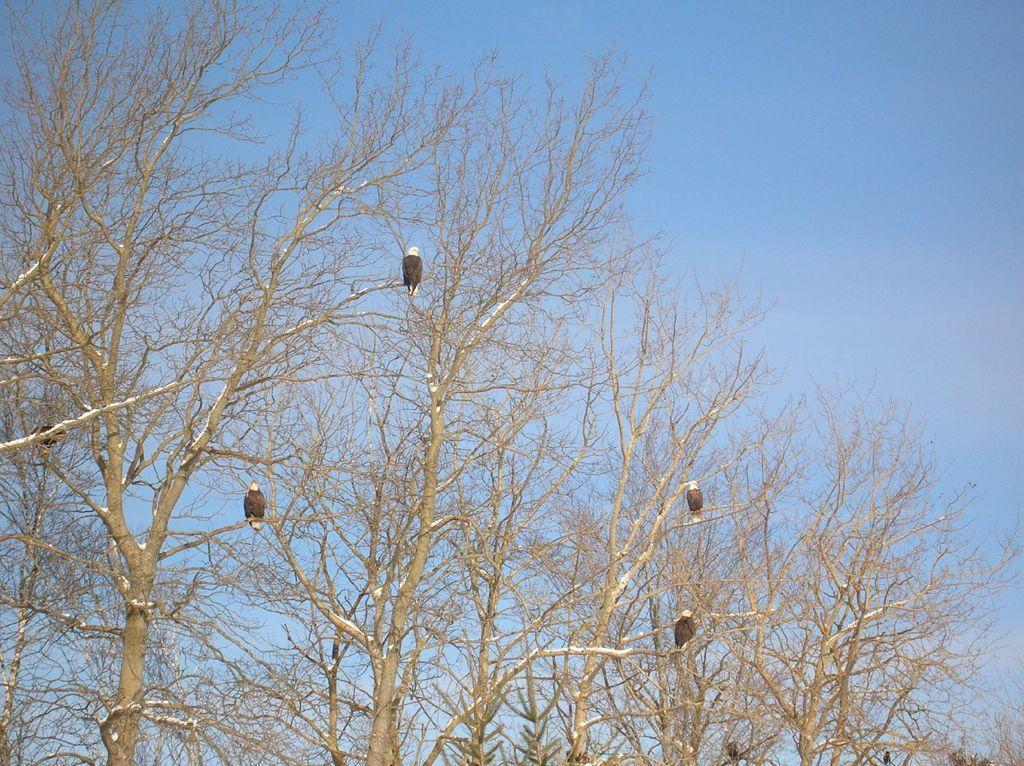Can you describe this image briefly? In this image we can see a few birds on the tree branch. In the background, we can see the blue color sky. 